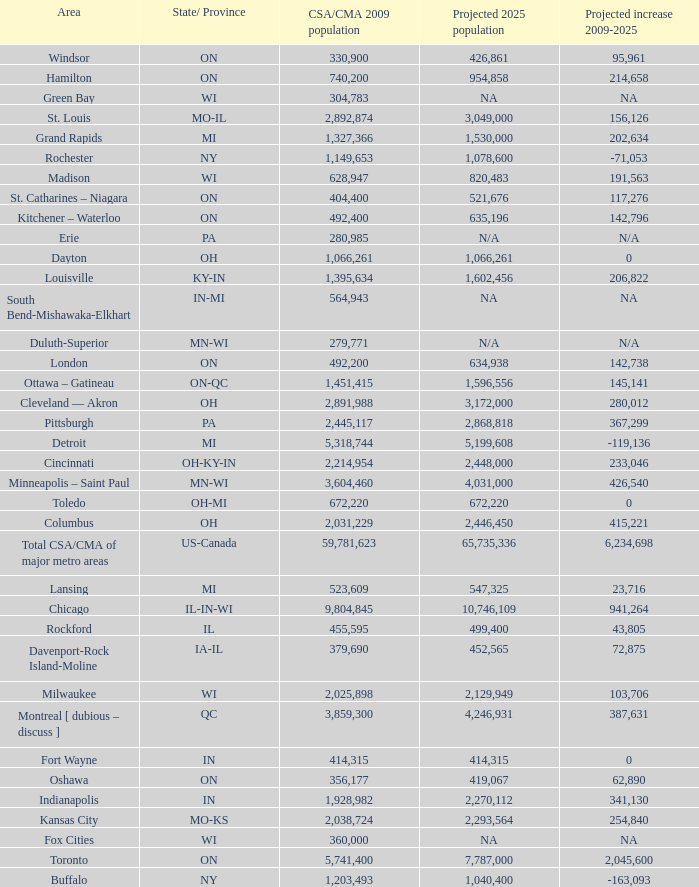What's the projected population of IN-MI? NA. 